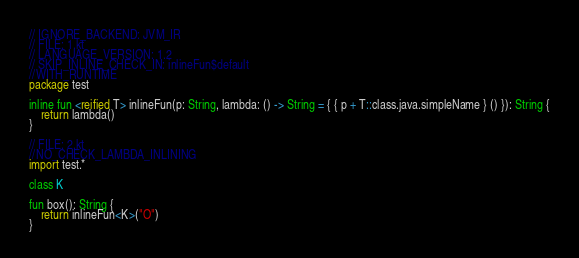<code> <loc_0><loc_0><loc_500><loc_500><_Kotlin_>// IGNORE_BACKEND: JVM_IR
// FILE: 1.kt
// LANGUAGE_VERSION: 1.2
// SKIP_INLINE_CHECK_IN: inlineFun$default
//WITH_RUNTIME
package test

inline fun <reified T> inlineFun(p: String, lambda: () -> String = { { p + T::class.java.simpleName } () }): String {
    return lambda()
}

// FILE: 2.kt
//NO_CHECK_LAMBDA_INLINING
import test.*

class K

fun box(): String {
    return inlineFun<K>("O")
}
</code> 